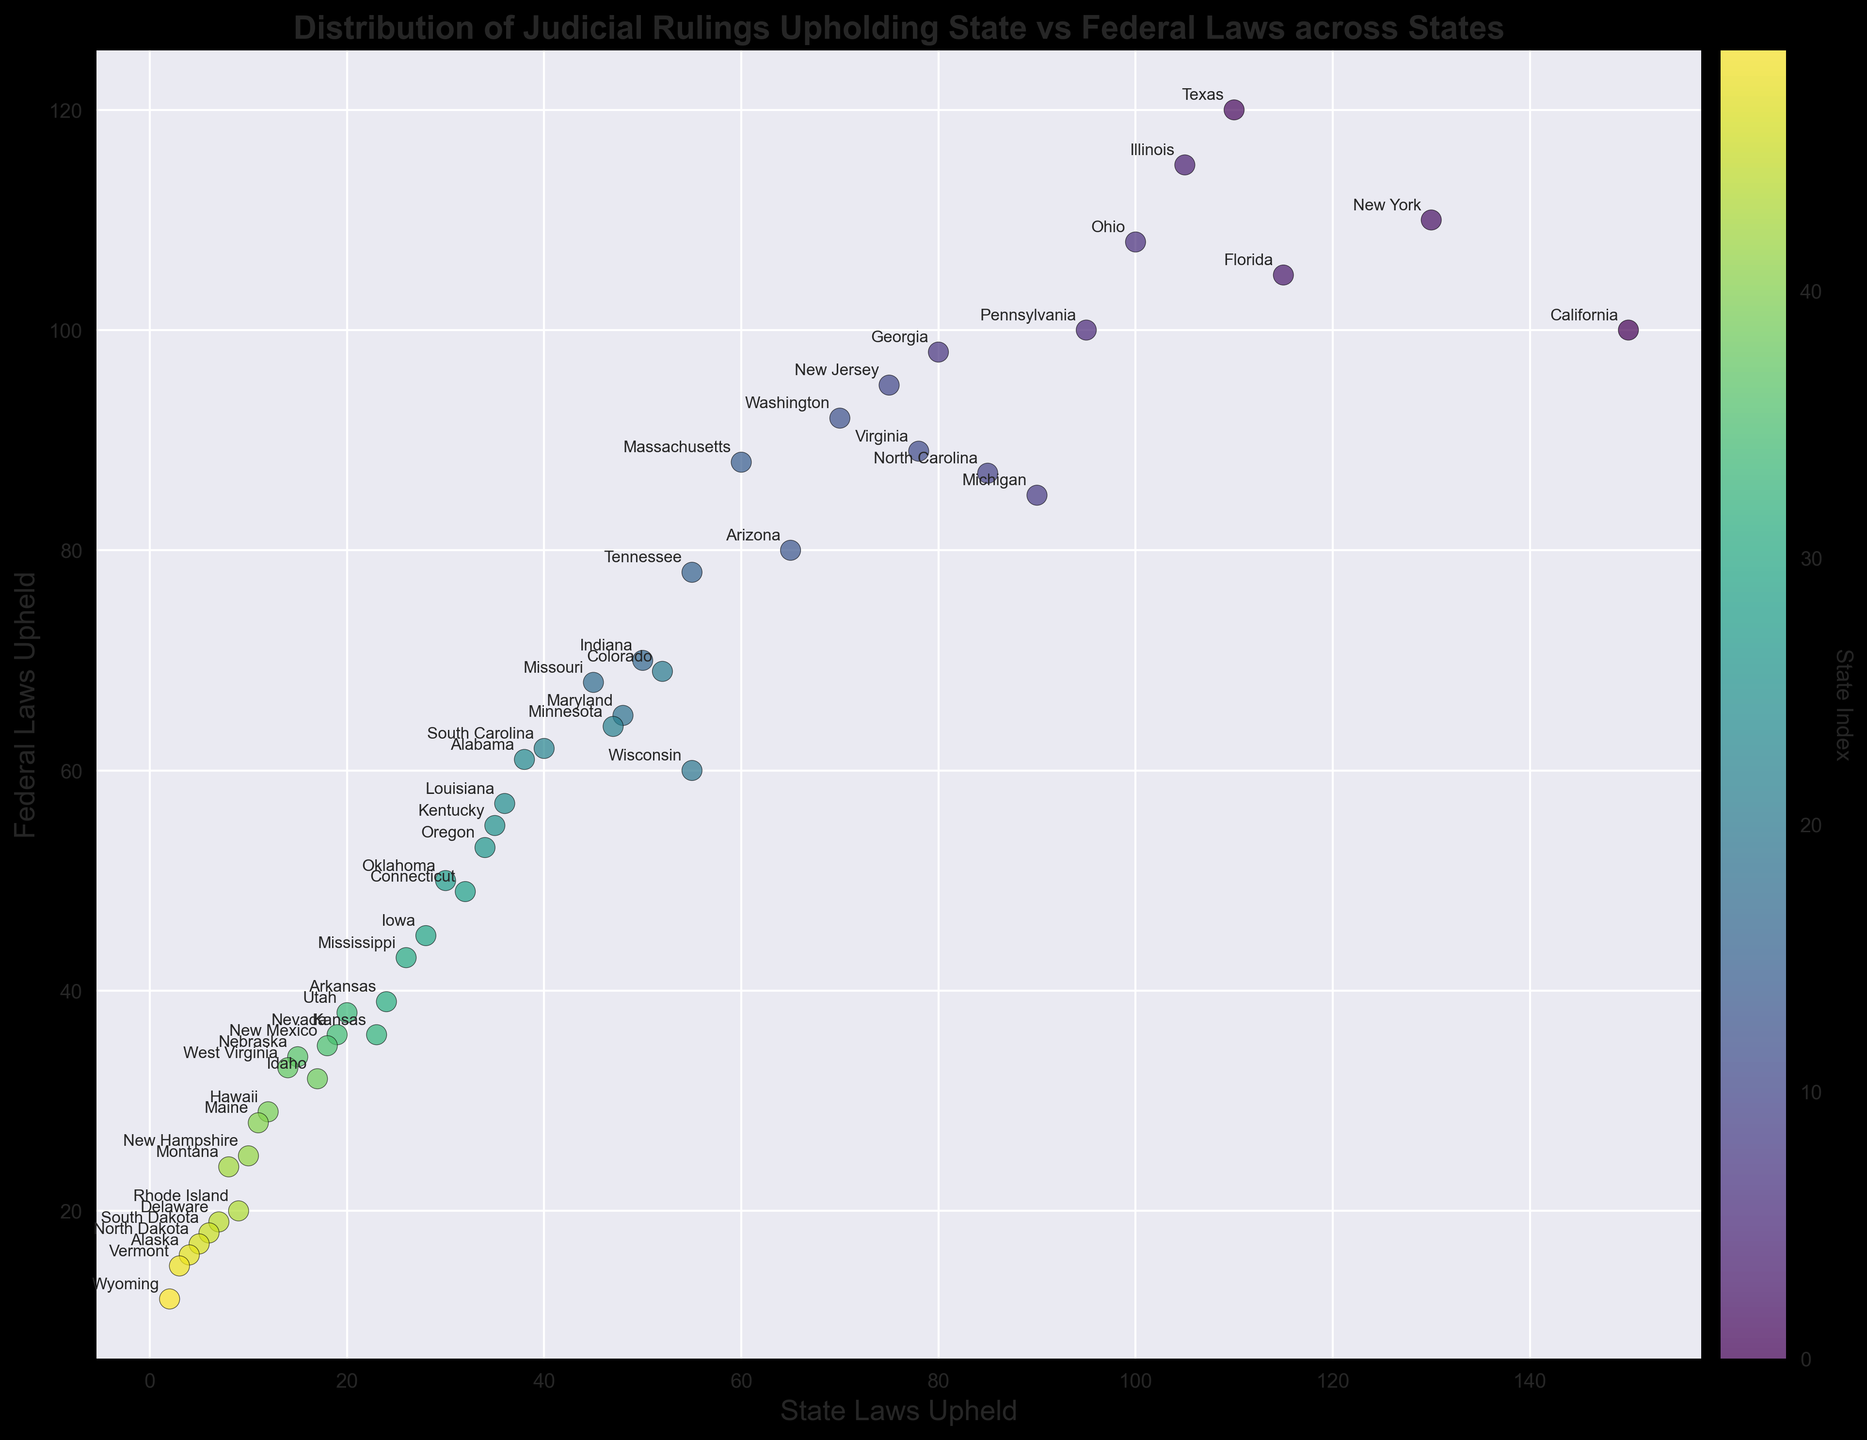Which state had the highest number of judicial rulings upholding state laws? To identify the state with the highest number of judicial rulings upholding state laws, look for the point with the largest 'State Laws Upheld' value on the x-axis. California is at 150, which is the highest.
Answer: California Which state upheld more federal laws than state laws by the largest margin? To find the state with the greatest difference where federal laws upheld are more than state laws, calculate the difference between 'Federal Laws Upheld' and 'State Laws Upheld' for each state. Delaware has the largest margin (19 - 7 = 12).
Answer: Delaware How many states have their number of upheld state laws higher than federal laws upheld? Count the states where 'State Laws Upheld' value is greater than 'Federal Laws Upheld'. This can be visually assessed by comparing x-axis and y-axis values for each state. The states are California, New York, Florida, Pennsylvania, Ohio, Michigan, North Carolina, and New Jersey, making a total of 8 states.
Answer: 8 Which state has the lowest number of judicial rulings upholding federal laws? Look for the point with the smallest 'Federal Laws Upheld' value on the y-axis. Wyoming has the lowest with 12.
Answer: Wyoming What is the average number of state laws upheld across Tennessee, Indiana, and Missouri? Add the values of 'State Laws Upheld' for Tennessee (55), Indiana (50), and Missouri (45), then divide by 3. (55+50+45)/3 = 50.
Answer: 50 Is the number of federal laws upheld greater than state laws upheld for Texas? Compare 'State Laws Upheld' (110) and 'Federal Laws Upheld' (120) for Texas. 120 (Federal) is greater than 110 (State).
Answer: Yes Which state is located at the intersection of 60 state laws upheld and 88 federal laws upheld? Identify the state situated at the coordinates (60, 88) on the scatter plot. Massachusetts is at the coordinates (60, 88).
Answer: Massachusetts Compare the difference between federal and state laws upheld in Michigan versus Georgia. Which state has a greater difference? For Michigan: Federal Laws Upheld = 85, State Laws Upheld = 90, difference = 90-85 = 5. For Georgia: Federal Laws Upheld = 98, State Laws Upheld = 80, difference = 98-80 = 18. Georgia has the greater difference.
Answer: Georgia How many states upheld between 50 and 100 federal laws? Count the number of points that fall between 50 and 100 on the 'Federal Laws Upheld' axis. These states are Illinois, Pennsylvania, Ohio, Georgia, Michigan, North Carolina, New Jersey, Virginia, Washington, Arizona, Massachusetts, Tennessee, Indiana, Missouri, Maryland, Wisconsin, South Carolina, Alabama, Louisiana, Kentucky, Oregon, Oklahoma, Connecticut, Iowa, Mississippi, Arkansas, Kansas, Utah, Nevada, New Mexico, Nebraska, West Virginia, Idaho, Hawaii, Maine, New Hampshire, Montana, Rhode Island, Delaware, South Dakota, North Dakota, Alaska, Vermont, and Wyoming, making a total of 42 states.
Answer: 42 For the states with fewer than 20 state laws upheld, which one has the highest number of federal laws upheld? Identify the states where 'State Laws Upheld' is less than 20, then among these, find the one with the highest 'Federal Laws Upheld'. Wyoming has 12.
Answer: Wyoming 